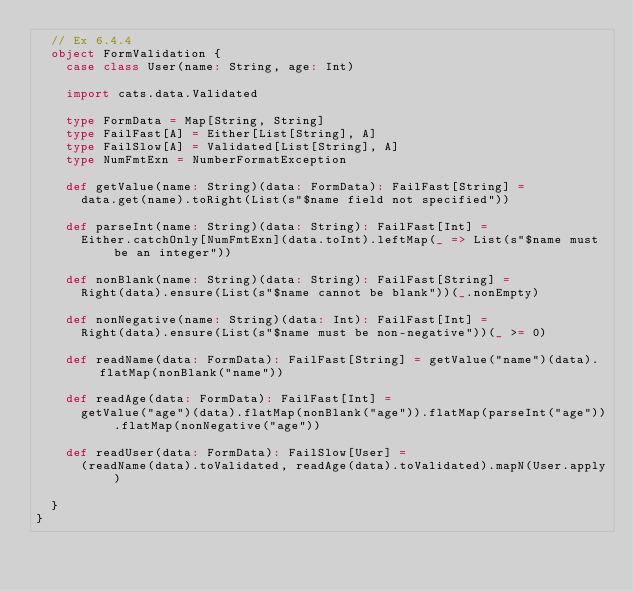<code> <loc_0><loc_0><loc_500><loc_500><_Scala_>  // Ex 6.4.4
  object FormValidation {
    case class User(name: String, age: Int)

    import cats.data.Validated

    type FormData = Map[String, String]
    type FailFast[A] = Either[List[String], A]
    type FailSlow[A] = Validated[List[String], A]
    type NumFmtExn = NumberFormatException

    def getValue(name: String)(data: FormData): FailFast[String] =
      data.get(name).toRight(List(s"$name field not specified"))

    def parseInt(name: String)(data: String): FailFast[Int] =
      Either.catchOnly[NumFmtExn](data.toInt).leftMap(_ => List(s"$name must be an integer"))

    def nonBlank(name: String)(data: String): FailFast[String] =
      Right(data).ensure(List(s"$name cannot be blank"))(_.nonEmpty)

    def nonNegative(name: String)(data: Int): FailFast[Int] =
      Right(data).ensure(List(s"$name must be non-negative"))(_ >= 0)

    def readName(data: FormData): FailFast[String] = getValue("name")(data).flatMap(nonBlank("name"))

    def readAge(data: FormData): FailFast[Int] =
      getValue("age")(data).flatMap(nonBlank("age")).flatMap(parseInt("age")).flatMap(nonNegative("age"))

    def readUser(data: FormData): FailSlow[User] =
      (readName(data).toValidated, readAge(data).toValidated).mapN(User.apply)

  }
}
</code> 